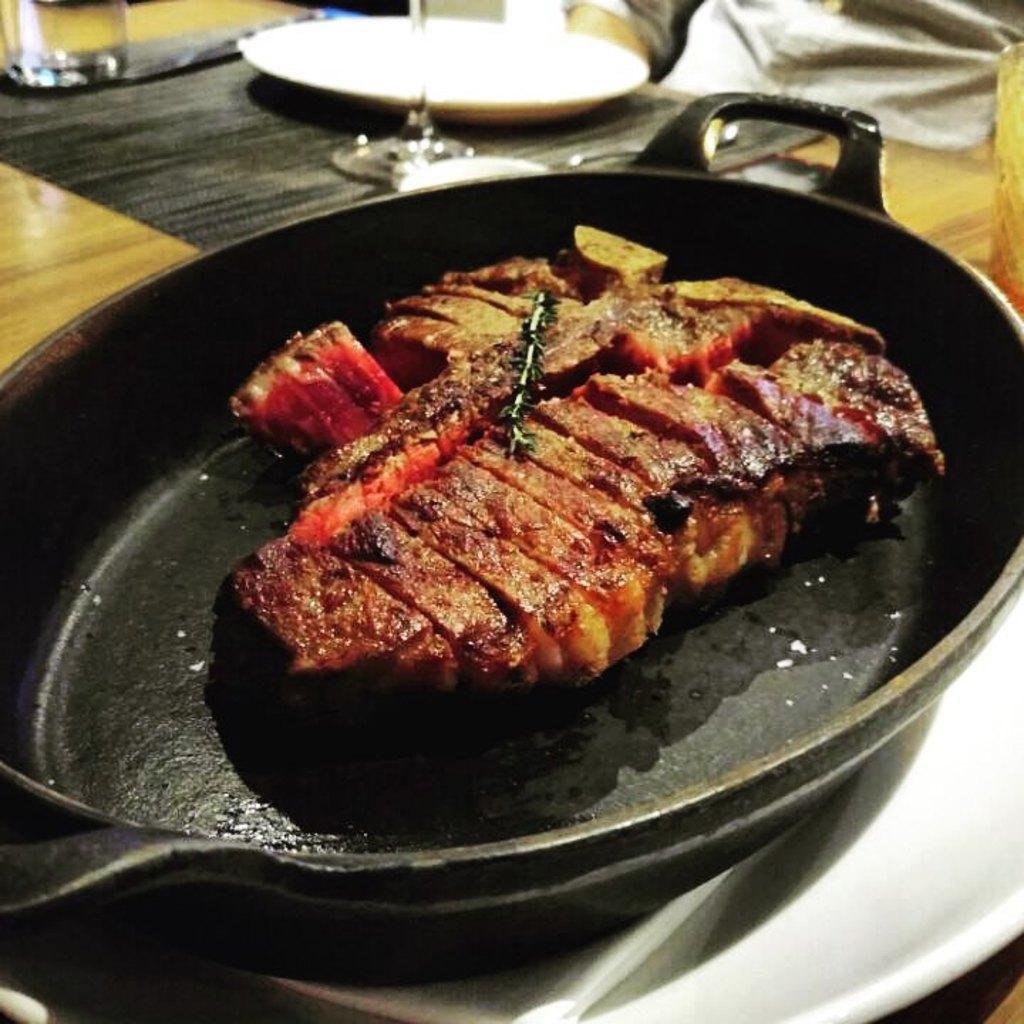Describe this image in one or two sentences. In this picture we can see food in the pan, beside the pan we can see a plate, glasses and other things on the table. 